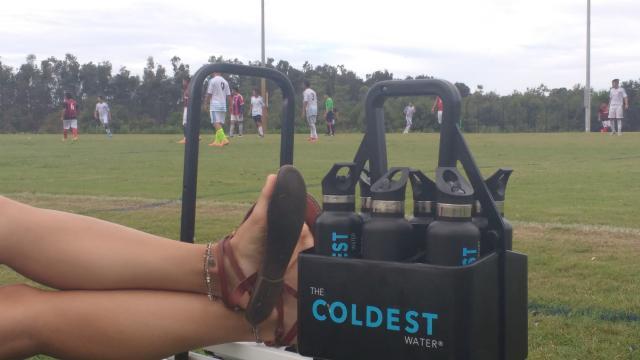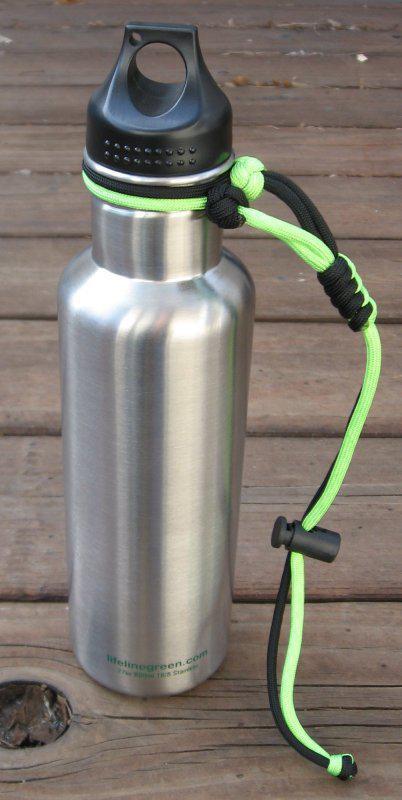The first image is the image on the left, the second image is the image on the right. Given the left and right images, does the statement "singular water bottles are surrounded by rop" hold true? Answer yes or no. No. The first image is the image on the left, the second image is the image on the right. Assess this claim about the two images: "There is at least one disposable water bottle with a white cap.". Correct or not? Answer yes or no. No. 